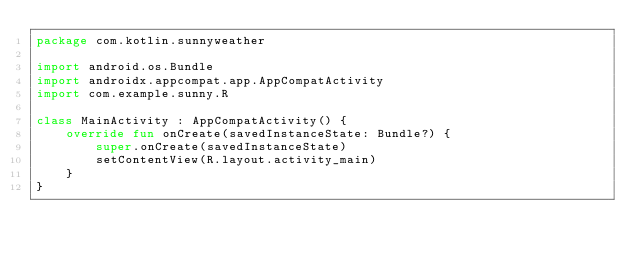Convert code to text. <code><loc_0><loc_0><loc_500><loc_500><_Kotlin_>package com.kotlin.sunnyweather

import android.os.Bundle
import androidx.appcompat.app.AppCompatActivity
import com.example.sunny.R

class MainActivity : AppCompatActivity() {
    override fun onCreate(savedInstanceState: Bundle?) {
        super.onCreate(savedInstanceState)
        setContentView(R.layout.activity_main)
    }
}</code> 